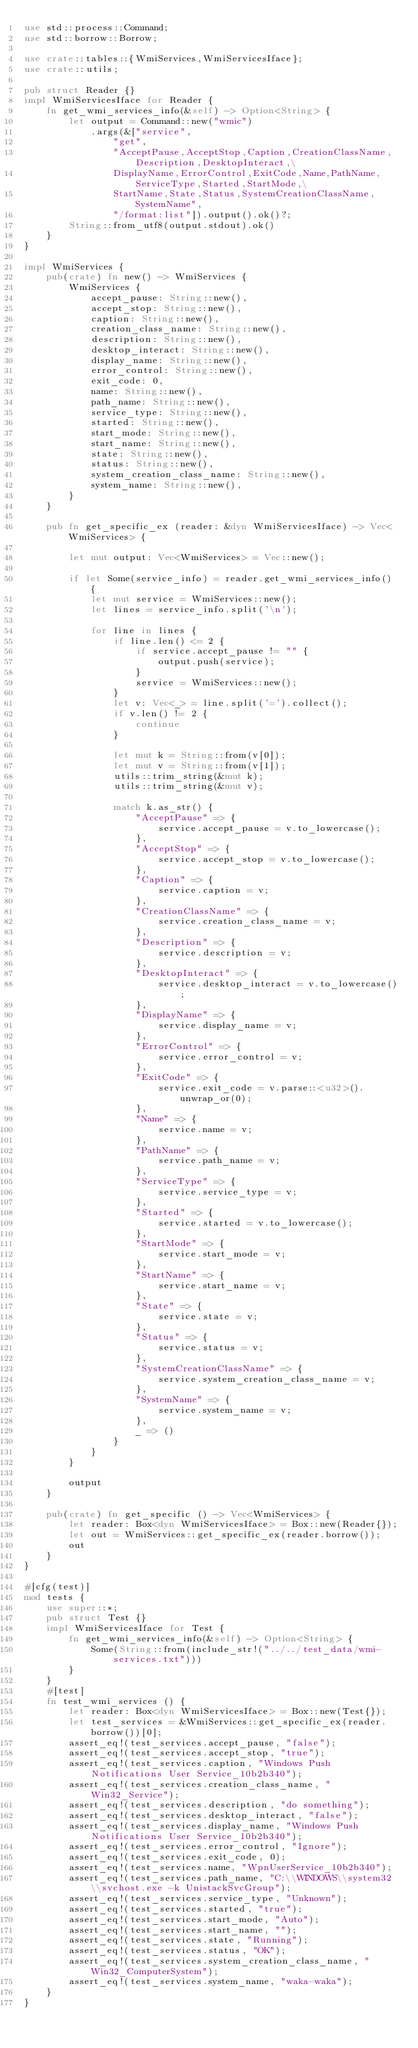Convert code to text. <code><loc_0><loc_0><loc_500><loc_500><_Rust_>use std::process::Command;
use std::borrow::Borrow;

use crate::tables::{WmiServices,WmiServicesIface};
use crate::utils;

pub struct Reader {}
impl WmiServicesIface for Reader {
    fn get_wmi_services_info(&self) -> Option<String> {
        let output = Command::new("wmic")
            .args(&["service",
                "get",
                "AcceptPause,AcceptStop,Caption,CreationClassName,Description,DesktopInteract,\
                DisplayName,ErrorControl,ExitCode,Name,PathName,ServiceType,Started,StartMode,\
                StartName,State,Status,SystemCreationClassName,SystemName",
                "/format:list"]).output().ok()?;
        String::from_utf8(output.stdout).ok()
    }
}

impl WmiServices {
    pub(crate) fn new() -> WmiServices {
        WmiServices {
            accept_pause: String::new(),
            accept_stop: String::new(),
            caption: String::new(),
            creation_class_name: String::new(),
            description: String::new(),
            desktop_interact: String::new(),
            display_name: String::new(),
            error_control: String::new(),
            exit_code: 0,
            name: String::new(),
            path_name: String::new(),
            service_type: String::new(),
            started: String::new(),
            start_mode: String::new(),
            start_name: String::new(),
            state: String::new(),
            status: String::new(),
            system_creation_class_name: String::new(),
            system_name: String::new(),
        }
    }

    pub fn get_specific_ex (reader: &dyn WmiServicesIface) -> Vec<WmiServices> {

        let mut output: Vec<WmiServices> = Vec::new();

        if let Some(service_info) = reader.get_wmi_services_info() {
            let mut service = WmiServices::new();
            let lines = service_info.split('\n');

            for line in lines {
                if line.len() <= 2 {
                    if service.accept_pause != "" {
                        output.push(service);
                    }
                    service = WmiServices::new();
                }
                let v: Vec<_> = line.split('=').collect();
                if v.len() != 2 {
                    continue
                }

                let mut k = String::from(v[0]);
                let mut v = String::from(v[1]);
                utils::trim_string(&mut k);
                utils::trim_string(&mut v);

                match k.as_str() {
                    "AcceptPause" => {
                        service.accept_pause = v.to_lowercase();
                    },
                    "AcceptStop" => {
                        service.accept_stop = v.to_lowercase();
                    },
                    "Caption" => {
                        service.caption = v;
                    },
                    "CreationClassName" => {
                        service.creation_class_name = v;
                    },
                    "Description" => {
                        service.description = v;
                    },
                    "DesktopInteract" => {
                        service.desktop_interact = v.to_lowercase();
                    },
                    "DisplayName" => {
                        service.display_name = v;
                    },
                    "ErrorControl" => {
                        service.error_control = v;
                    },
                    "ExitCode" => {
                        service.exit_code = v.parse::<u32>().unwrap_or(0);
                    },
                    "Name" => {
                        service.name = v;
                    },
                    "PathName" => {
                        service.path_name = v;
                    },
                    "ServiceType" => {
                        service.service_type = v;
                    },
                    "Started" => {
                        service.started = v.to_lowercase();
                    },
                    "StartMode" => {
                        service.start_mode = v;
                    },
                    "StartName" => {
                        service.start_name = v;
                    },
                    "State" => {
                        service.state = v;
                    },
                    "Status" => {
                        service.status = v;
                    },
                    "SystemCreationClassName" => {
                        service.system_creation_class_name = v;
                    },
                    "SystemName" => {
                        service.system_name = v;
                    },
                    _ => ()
                }
            }
        }

        output
    }

    pub(crate) fn get_specific () -> Vec<WmiServices> {
        let reader: Box<dyn WmiServicesIface> = Box::new(Reader{});
        let out = WmiServices::get_specific_ex(reader.borrow());
        out
    }
}

#[cfg(test)]
mod tests {
    use super::*;
    pub struct Test {}
    impl WmiServicesIface for Test {
        fn get_wmi_services_info(&self) -> Option<String> {
            Some(String::from(include_str!("../../test_data/wmi-services.txt")))
        }
    }
    #[test]
    fn test_wmi_services () {
        let reader: Box<dyn WmiServicesIface> = Box::new(Test{});
        let test_services = &WmiServices::get_specific_ex(reader.borrow())[0];
        assert_eq!(test_services.accept_pause, "false");
        assert_eq!(test_services.accept_stop, "true");
        assert_eq!(test_services.caption, "Windows Push Notifications User Service_10b2b340");
        assert_eq!(test_services.creation_class_name, "Win32_Service");
        assert_eq!(test_services.description, "do something");
        assert_eq!(test_services.desktop_interact, "false");
        assert_eq!(test_services.display_name, "Windows Push Notifications User Service_10b2b340");
        assert_eq!(test_services.error_control, "Ignore");
        assert_eq!(test_services.exit_code, 0);
        assert_eq!(test_services.name, "WpnUserService_10b2b340");
        assert_eq!(test_services.path_name, "C:\\WINDOWS\\system32\\svchost.exe -k UnistackSvcGroup");
        assert_eq!(test_services.service_type, "Unknown");
        assert_eq!(test_services.started, "true");
        assert_eq!(test_services.start_mode, "Auto");
        assert_eq!(test_services.start_name, "");
        assert_eq!(test_services.state, "Running");
        assert_eq!(test_services.status, "OK");
        assert_eq!(test_services.system_creation_class_name, "Win32_ComputerSystem");
        assert_eq!(test_services.system_name, "waka-waka");
    }
}</code> 